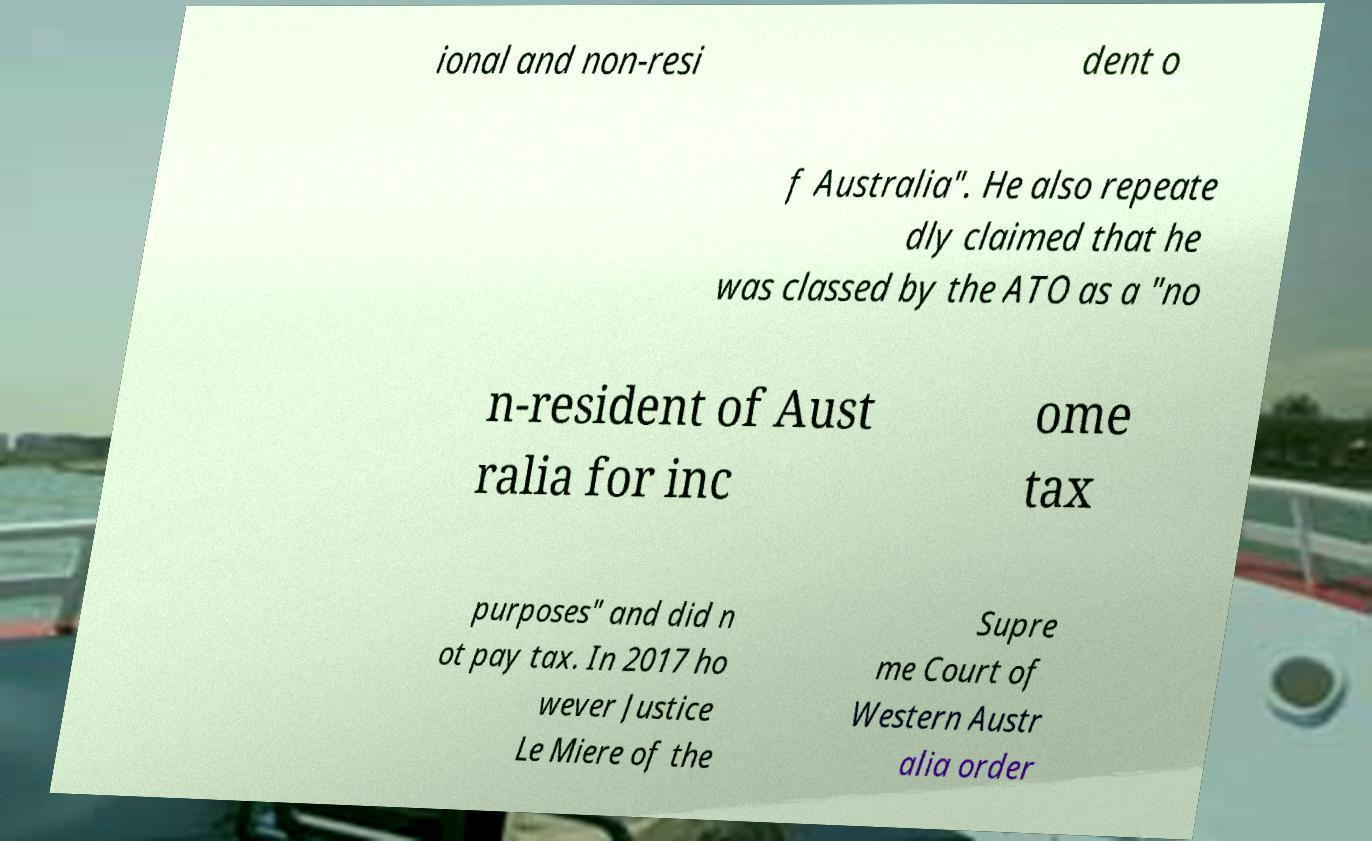Please read and relay the text visible in this image. What does it say? ional and non-resi dent o f Australia". He also repeate dly claimed that he was classed by the ATO as a "no n-resident of Aust ralia for inc ome tax purposes" and did n ot pay tax. In 2017 ho wever Justice Le Miere of the Supre me Court of Western Austr alia order 